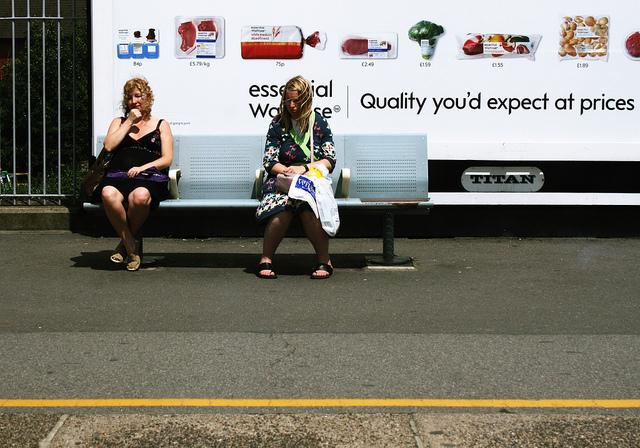Is this a bus stop?
Write a very short answer. Yes. What are these women waiting for?
Be succinct. Bus. Are they sisters?
Keep it brief. No. 